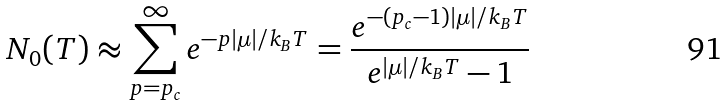Convert formula to latex. <formula><loc_0><loc_0><loc_500><loc_500>N _ { 0 } ( T ) \approx \sum _ { p = p _ { c } } ^ { \infty } e ^ { - p | \mu | / k _ { B } T } = \frac { e ^ { - ( p _ { c } - 1 ) | \mu | / k _ { B } T } } { e ^ { | \mu | / k _ { B } T } - 1 }</formula> 